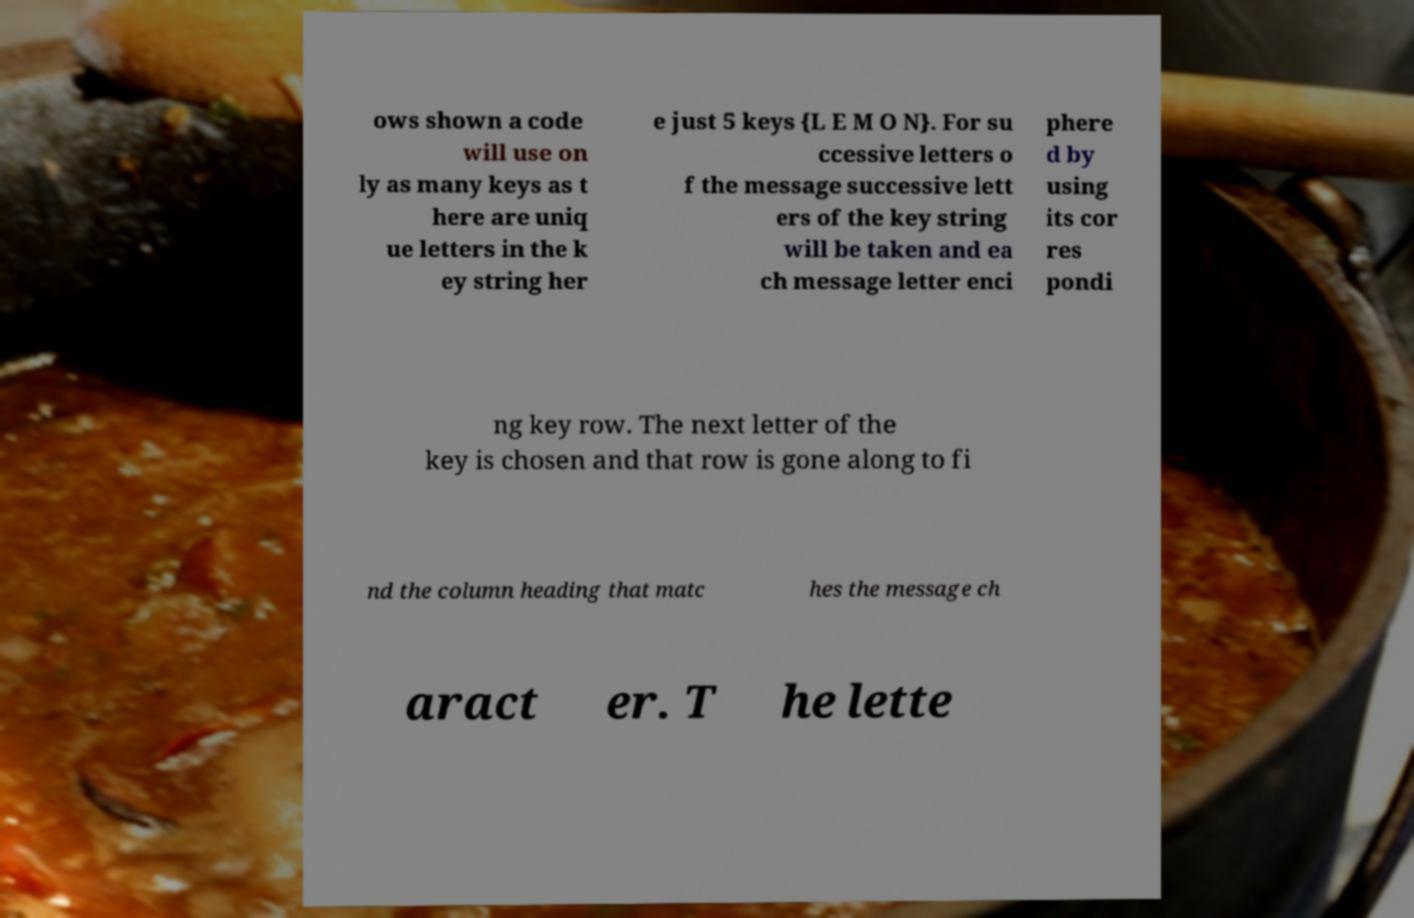I need the written content from this picture converted into text. Can you do that? ows shown a code will use on ly as many keys as t here are uniq ue letters in the k ey string her e just 5 keys {L E M O N}. For su ccessive letters o f the message successive lett ers of the key string will be taken and ea ch message letter enci phere d by using its cor res pondi ng key row. The next letter of the key is chosen and that row is gone along to fi nd the column heading that matc hes the message ch aract er. T he lette 